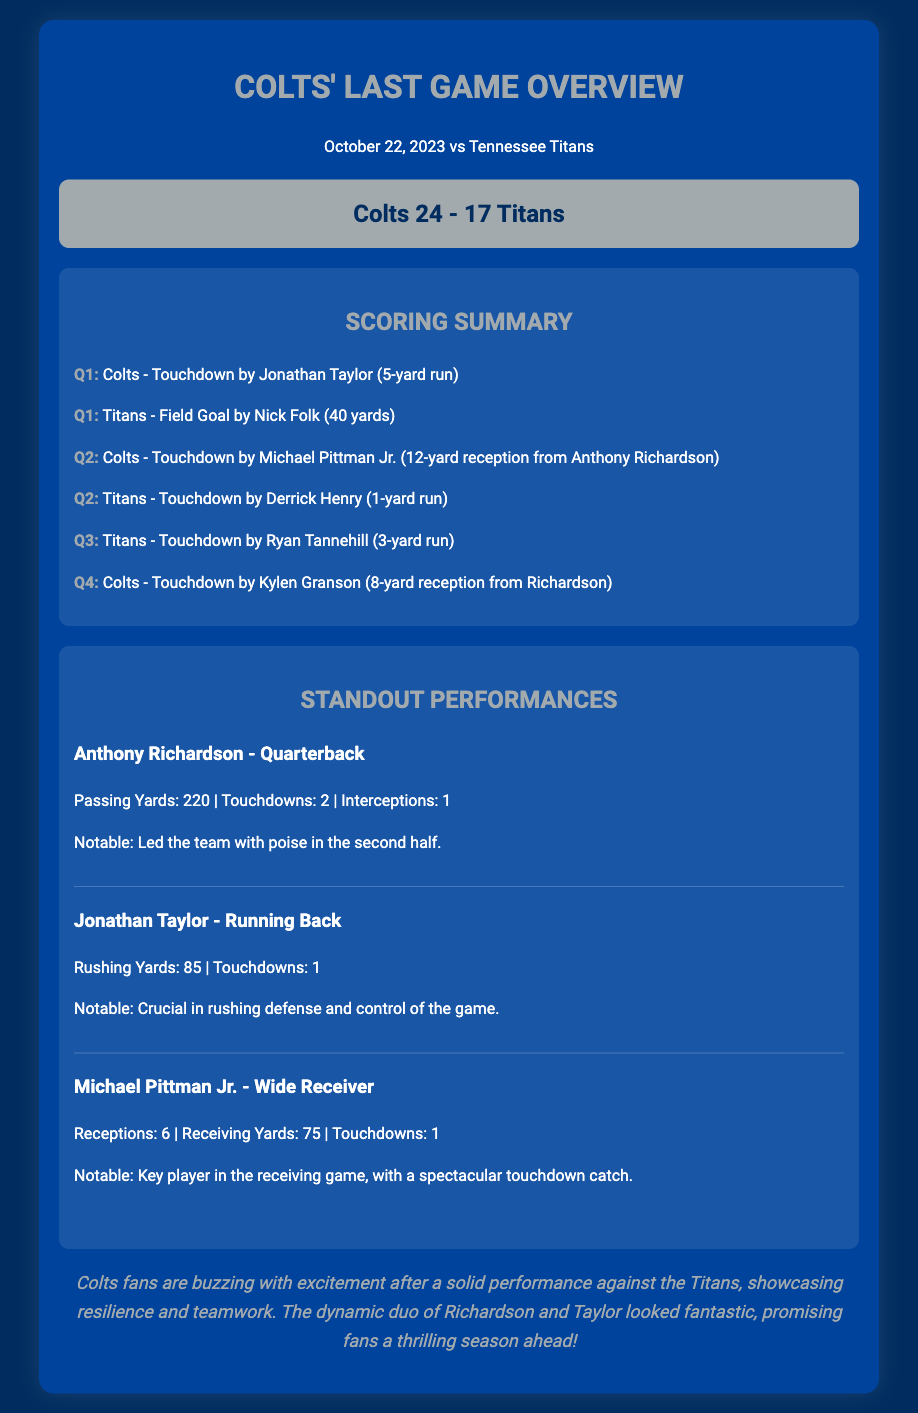What was the final score of the game? The final score is displayed in the scoreboard section of the document where the Colts' score and the Titans' score are shown.
Answer: Colts 24 - 17 Titans Who scored the first touchdown for the Colts? The first touchdown for the Colts is mentioned in the scoring summary, indicating the player who scored it.
Answer: Jonathan Taylor How many touchdowns did Anthony Richardson throw? The information regarding Anthony Richardson's performance includes the number of touchdowns he threw, which is specified in the standout performances section.
Answer: 2 What was Michael Pittman Jr.'s total receiving yards? Michael Pittman Jr.'s performance details include specifics such as his total receiving yards, located in the standout performances section.
Answer: 75 How many rushing yards did Jonathan Taylor have? Jonathan Taylor's performance statistics summarize his rushing yards in the standout performances section.
Answer: 85 What notable action did Anthony Richardson perform in the second half? The document states that he led the team with poise in the second half, which explains his notable contribution.
Answer: Led the team with poise Which quarter did the Colts score their last touchdown? The scoring summary details for each quarter show when the Colts scored their last touchdown.
Answer: Q4 What is the date of the game? The document explicitly mentions the date of the game at the top of the rendered content.
Answer: October 22, 2023 What player had a spectacular touchdown catch? The standout performances section contains a mention of the player who made a spectacular touchdown catch.
Answer: Michael Pittman Jr 